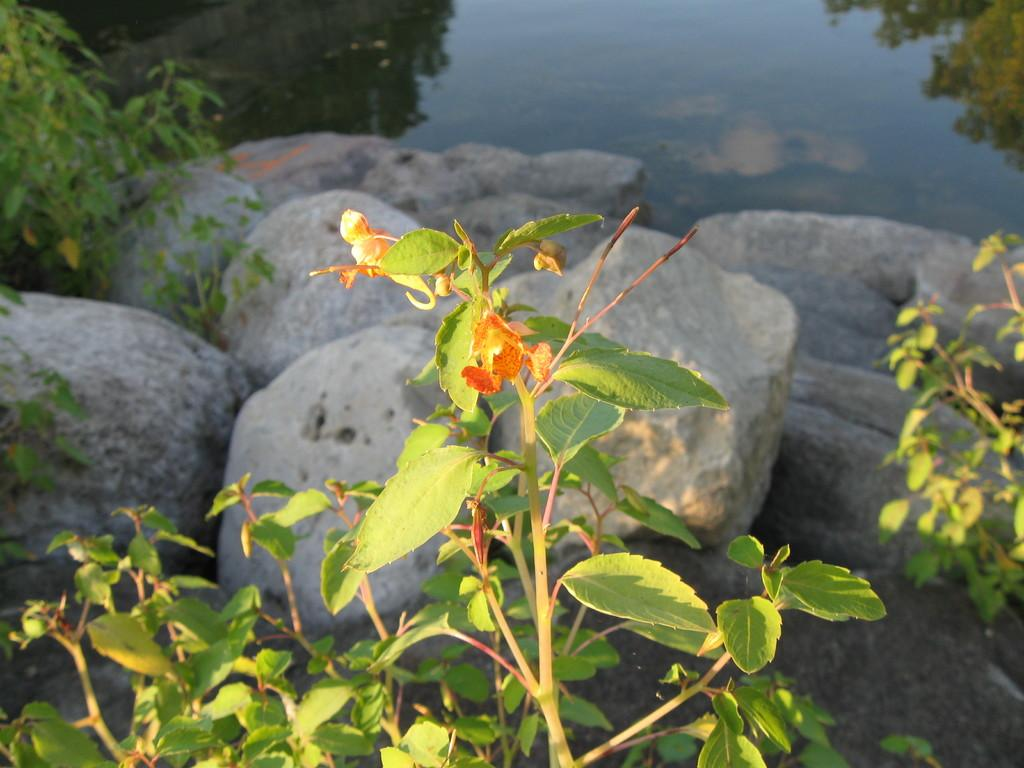What type of vegetation is present at the bottom of the picture? There are plants at the bottom of the picture. Where else can plants be found in the image? Plants can also be found on the left and right sides of the picture. What other elements are present in the image besides plants? There are rocks and water visible in the image. What type of chalk is being used to draw on the rocks in the image? There is no chalk present in the image, and no drawing activity is depicted. 